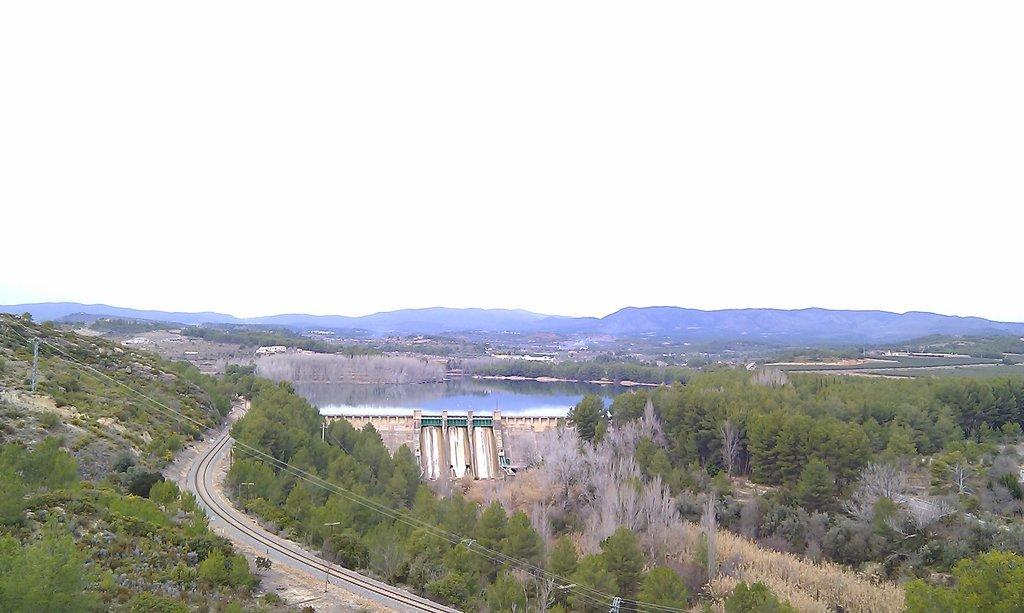What is the main feature of the image? The main feature of the image is a dam. What can be seen in the water in the image? There is no specific detail about the water in the image. What type of vegetation is present in the image? There are trees in the image. What type of infrastructure can be seen in the image? There is a road and a railway track in the image. What other structures are present in the image? There are poles in the image. What type of terrain is visible in the image? There are hills in the image. What is visible in the sky in the image? The sky is visible in the image. What type of produce is being harvested by the dinosaurs in the image? There are no dinosaurs present in the image, and therefore no produce is being harvested. 